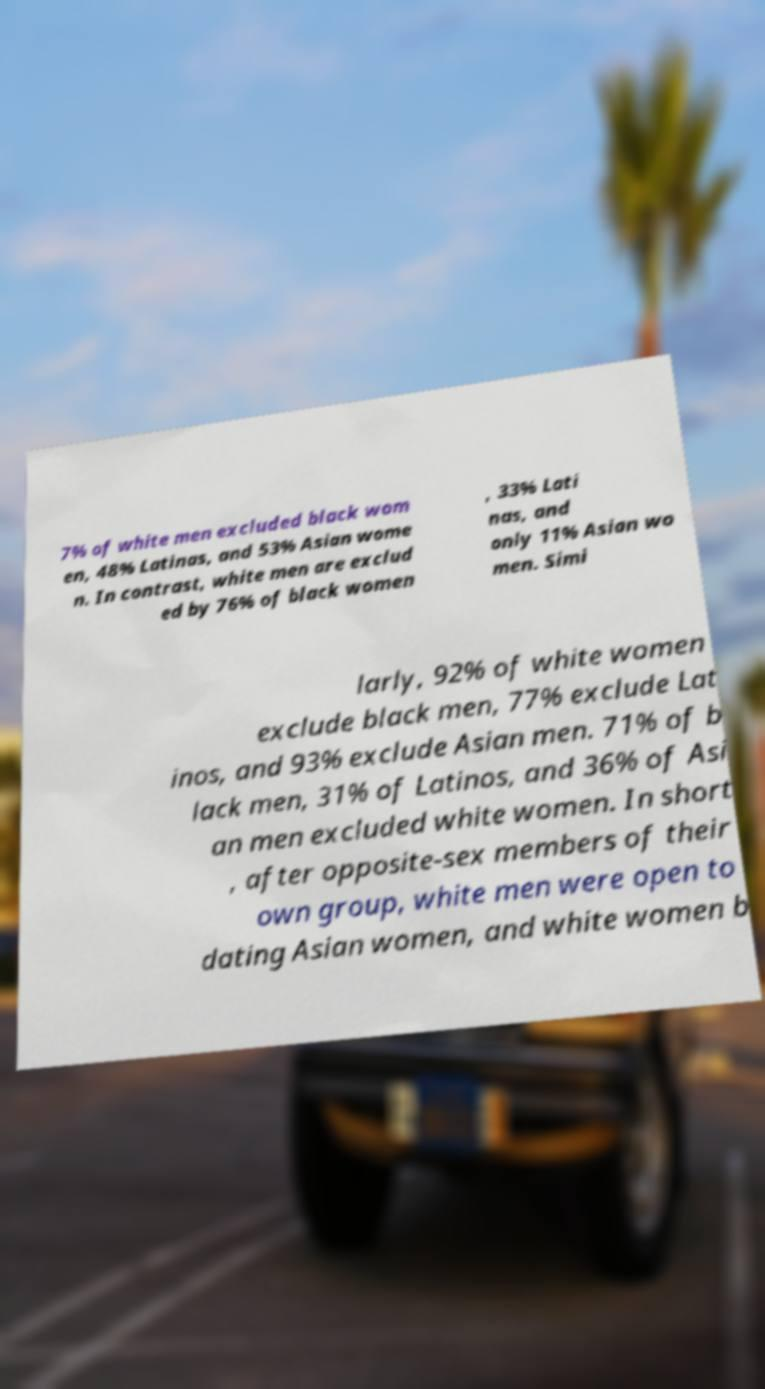There's text embedded in this image that I need extracted. Can you transcribe it verbatim? 7% of white men excluded black wom en, 48% Latinas, and 53% Asian wome n. In contrast, white men are exclud ed by 76% of black women , 33% Lati nas, and only 11% Asian wo men. Simi larly, 92% of white women exclude black men, 77% exclude Lat inos, and 93% exclude Asian men. 71% of b lack men, 31% of Latinos, and 36% of Asi an men excluded white women. In short , after opposite-sex members of their own group, white men were open to dating Asian women, and white women b 